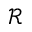<formula> <loc_0><loc_0><loc_500><loc_500>\mathcal { R }</formula> 